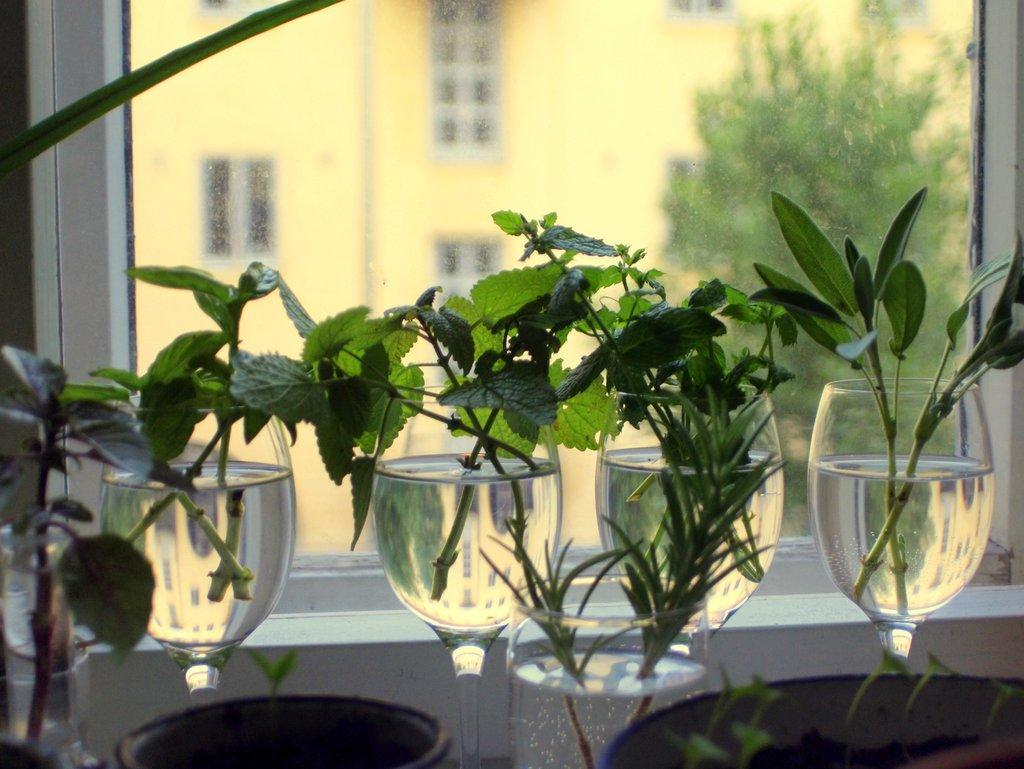In one or two sentences, can you explain what this image depicts? At the bottom of the image we can see round shape objects. In the center of the image we can see the glasses. In the glasses, we can see water and plants. In the background there is a wall, glass window, one stick type object and a few other objects. Through glass window, we can see the building, windows, one tree and a few other objects. 